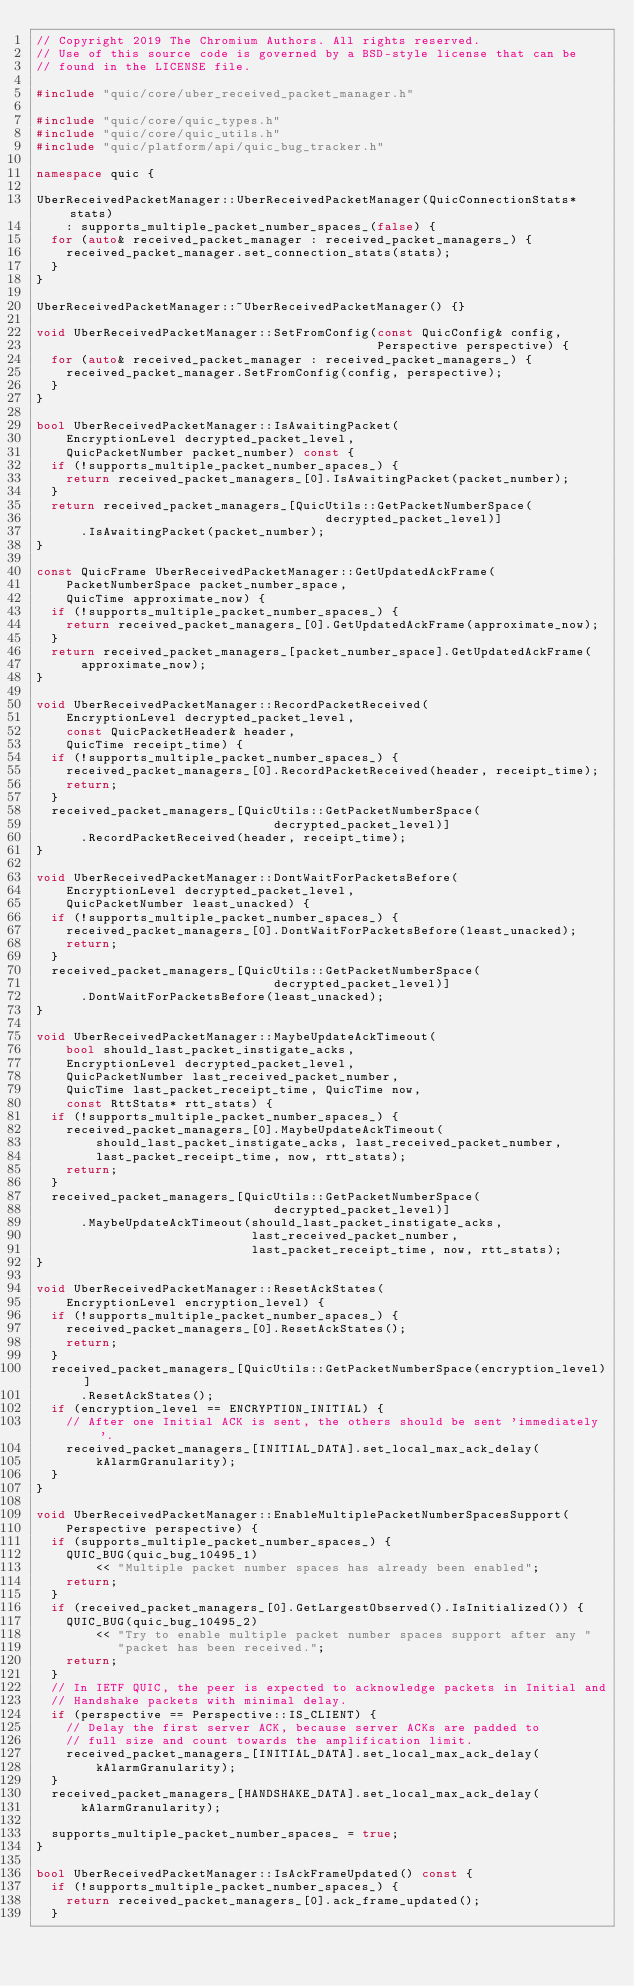<code> <loc_0><loc_0><loc_500><loc_500><_C++_>// Copyright 2019 The Chromium Authors. All rights reserved.
// Use of this source code is governed by a BSD-style license that can be
// found in the LICENSE file.

#include "quic/core/uber_received_packet_manager.h"

#include "quic/core/quic_types.h"
#include "quic/core/quic_utils.h"
#include "quic/platform/api/quic_bug_tracker.h"

namespace quic {

UberReceivedPacketManager::UberReceivedPacketManager(QuicConnectionStats* stats)
    : supports_multiple_packet_number_spaces_(false) {
  for (auto& received_packet_manager : received_packet_managers_) {
    received_packet_manager.set_connection_stats(stats);
  }
}

UberReceivedPacketManager::~UberReceivedPacketManager() {}

void UberReceivedPacketManager::SetFromConfig(const QuicConfig& config,
                                              Perspective perspective) {
  for (auto& received_packet_manager : received_packet_managers_) {
    received_packet_manager.SetFromConfig(config, perspective);
  }
}

bool UberReceivedPacketManager::IsAwaitingPacket(
    EncryptionLevel decrypted_packet_level,
    QuicPacketNumber packet_number) const {
  if (!supports_multiple_packet_number_spaces_) {
    return received_packet_managers_[0].IsAwaitingPacket(packet_number);
  }
  return received_packet_managers_[QuicUtils::GetPacketNumberSpace(
                                       decrypted_packet_level)]
      .IsAwaitingPacket(packet_number);
}

const QuicFrame UberReceivedPacketManager::GetUpdatedAckFrame(
    PacketNumberSpace packet_number_space,
    QuicTime approximate_now) {
  if (!supports_multiple_packet_number_spaces_) {
    return received_packet_managers_[0].GetUpdatedAckFrame(approximate_now);
  }
  return received_packet_managers_[packet_number_space].GetUpdatedAckFrame(
      approximate_now);
}

void UberReceivedPacketManager::RecordPacketReceived(
    EncryptionLevel decrypted_packet_level,
    const QuicPacketHeader& header,
    QuicTime receipt_time) {
  if (!supports_multiple_packet_number_spaces_) {
    received_packet_managers_[0].RecordPacketReceived(header, receipt_time);
    return;
  }
  received_packet_managers_[QuicUtils::GetPacketNumberSpace(
                                decrypted_packet_level)]
      .RecordPacketReceived(header, receipt_time);
}

void UberReceivedPacketManager::DontWaitForPacketsBefore(
    EncryptionLevel decrypted_packet_level,
    QuicPacketNumber least_unacked) {
  if (!supports_multiple_packet_number_spaces_) {
    received_packet_managers_[0].DontWaitForPacketsBefore(least_unacked);
    return;
  }
  received_packet_managers_[QuicUtils::GetPacketNumberSpace(
                                decrypted_packet_level)]
      .DontWaitForPacketsBefore(least_unacked);
}

void UberReceivedPacketManager::MaybeUpdateAckTimeout(
    bool should_last_packet_instigate_acks,
    EncryptionLevel decrypted_packet_level,
    QuicPacketNumber last_received_packet_number,
    QuicTime last_packet_receipt_time, QuicTime now,
    const RttStats* rtt_stats) {
  if (!supports_multiple_packet_number_spaces_) {
    received_packet_managers_[0].MaybeUpdateAckTimeout(
        should_last_packet_instigate_acks, last_received_packet_number,
        last_packet_receipt_time, now, rtt_stats);
    return;
  }
  received_packet_managers_[QuicUtils::GetPacketNumberSpace(
                                decrypted_packet_level)]
      .MaybeUpdateAckTimeout(should_last_packet_instigate_acks,
                             last_received_packet_number,
                             last_packet_receipt_time, now, rtt_stats);
}

void UberReceivedPacketManager::ResetAckStates(
    EncryptionLevel encryption_level) {
  if (!supports_multiple_packet_number_spaces_) {
    received_packet_managers_[0].ResetAckStates();
    return;
  }
  received_packet_managers_[QuicUtils::GetPacketNumberSpace(encryption_level)]
      .ResetAckStates();
  if (encryption_level == ENCRYPTION_INITIAL) {
    // After one Initial ACK is sent, the others should be sent 'immediately'.
    received_packet_managers_[INITIAL_DATA].set_local_max_ack_delay(
        kAlarmGranularity);
  }
}

void UberReceivedPacketManager::EnableMultiplePacketNumberSpacesSupport(
    Perspective perspective) {
  if (supports_multiple_packet_number_spaces_) {
    QUIC_BUG(quic_bug_10495_1)
        << "Multiple packet number spaces has already been enabled";
    return;
  }
  if (received_packet_managers_[0].GetLargestObserved().IsInitialized()) {
    QUIC_BUG(quic_bug_10495_2)
        << "Try to enable multiple packet number spaces support after any "
           "packet has been received.";
    return;
  }
  // In IETF QUIC, the peer is expected to acknowledge packets in Initial and
  // Handshake packets with minimal delay.
  if (perspective == Perspective::IS_CLIENT) {
    // Delay the first server ACK, because server ACKs are padded to
    // full size and count towards the amplification limit.
    received_packet_managers_[INITIAL_DATA].set_local_max_ack_delay(
        kAlarmGranularity);
  }
  received_packet_managers_[HANDSHAKE_DATA].set_local_max_ack_delay(
      kAlarmGranularity);

  supports_multiple_packet_number_spaces_ = true;
}

bool UberReceivedPacketManager::IsAckFrameUpdated() const {
  if (!supports_multiple_packet_number_spaces_) {
    return received_packet_managers_[0].ack_frame_updated();
  }</code> 